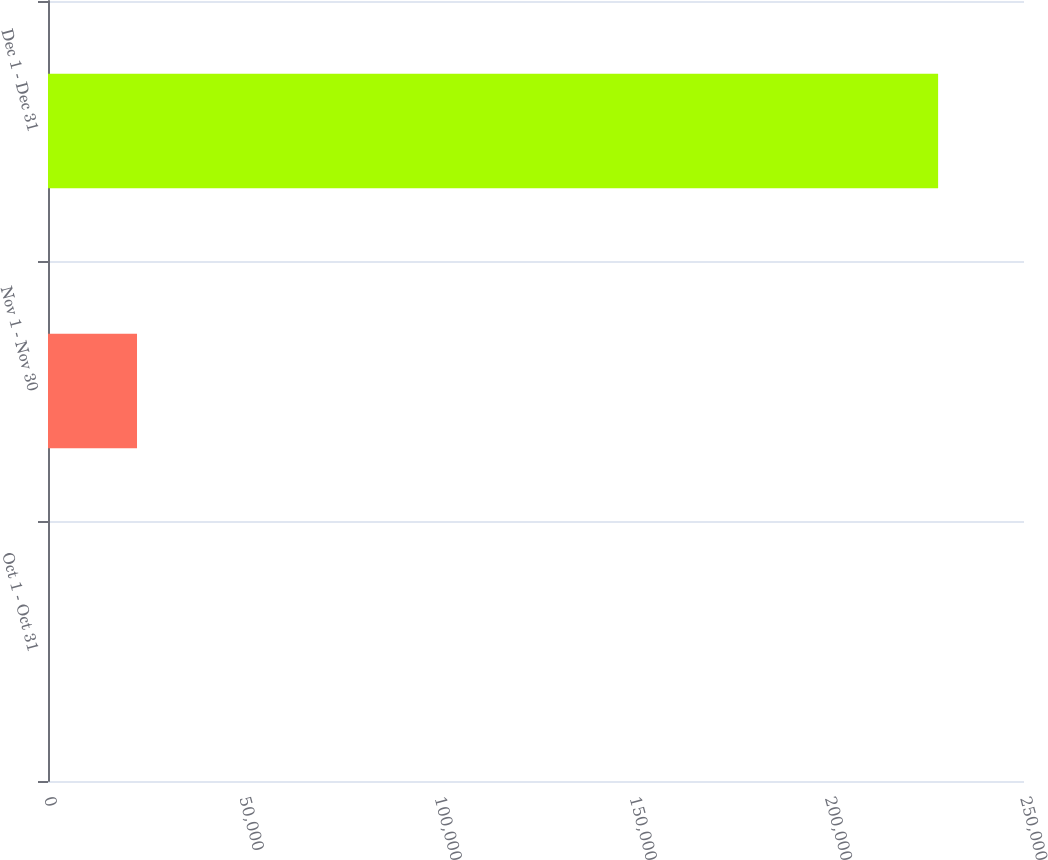Convert chart. <chart><loc_0><loc_0><loc_500><loc_500><bar_chart><fcel>Oct 1 - Oct 31<fcel>Nov 1 - Nov 30<fcel>Dec 1 - Dec 31<nl><fcel>0.17<fcel>22800.2<fcel>228000<nl></chart> 